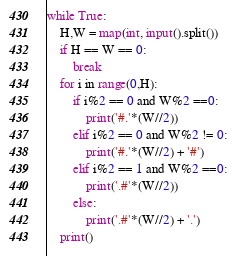Convert code to text. <code><loc_0><loc_0><loc_500><loc_500><_Python_>while True:
    H,W = map(int, input().split())
    if H == W == 0:
        break
    for i in range(0,H):
        if i%2 == 0 and W%2 ==0:
            print('#.'*(W//2))
        elif i%2 == 0 and W%2 != 0:
            print('#.'*(W//2) + '#')
        elif i%2 == 1 and W%2 ==0:
            print('.#'*(W//2))
        else:
            print('.#'*(W//2) + '.')
    print()
</code> 